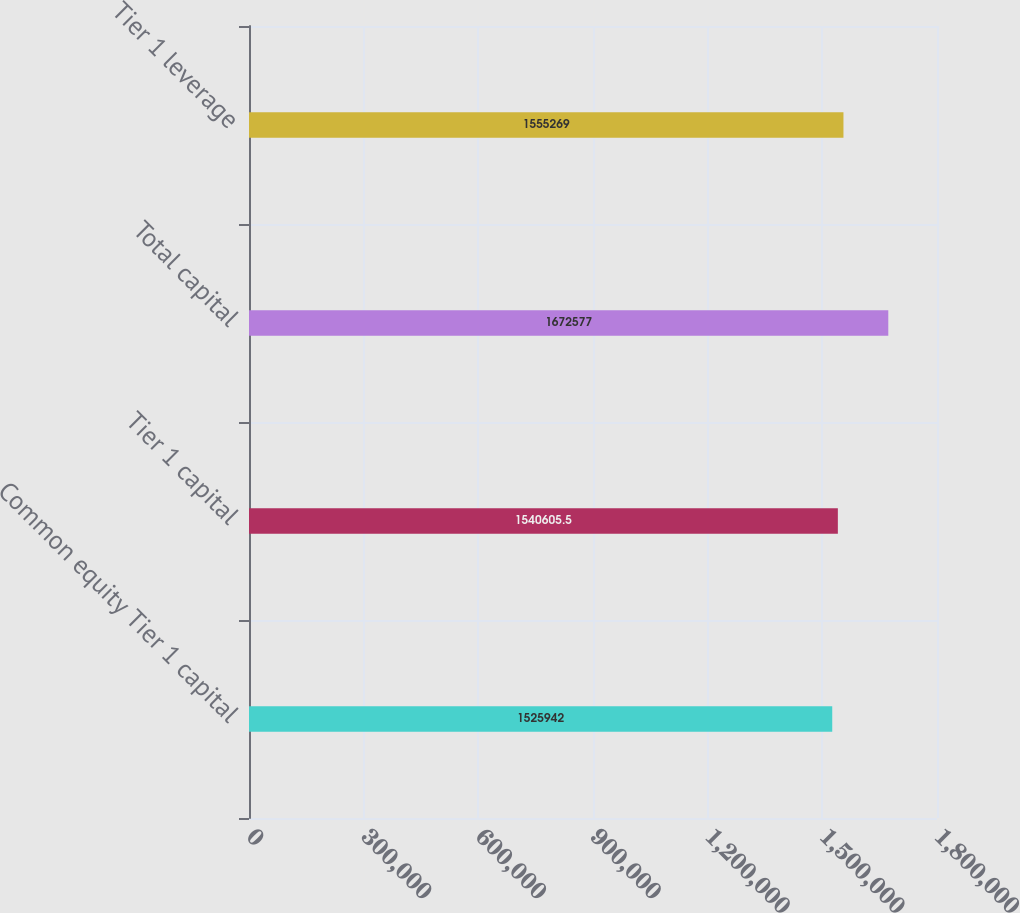Convert chart to OTSL. <chart><loc_0><loc_0><loc_500><loc_500><bar_chart><fcel>Common equity Tier 1 capital<fcel>Tier 1 capital<fcel>Total capital<fcel>Tier 1 leverage<nl><fcel>1.52594e+06<fcel>1.54061e+06<fcel>1.67258e+06<fcel>1.55527e+06<nl></chart> 